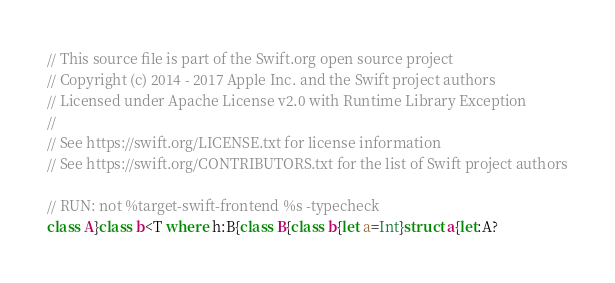<code> <loc_0><loc_0><loc_500><loc_500><_Swift_>// This source file is part of the Swift.org open source project
// Copyright (c) 2014 - 2017 Apple Inc. and the Swift project authors
// Licensed under Apache License v2.0 with Runtime Library Exception
//
// See https://swift.org/LICENSE.txt for license information
// See https://swift.org/CONTRIBUTORS.txt for the list of Swift project authors

// RUN: not %target-swift-frontend %s -typecheck
class A}class b<T where h:B{class B{class b{let a=Int}struct a{let:A?
</code> 